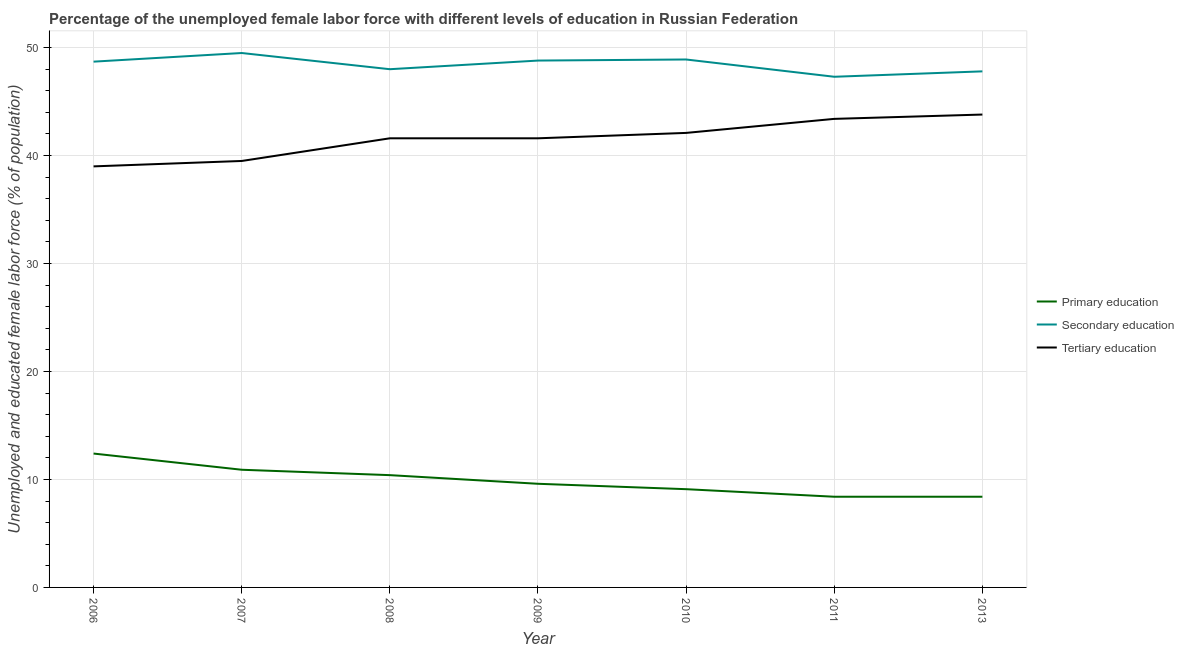Is the number of lines equal to the number of legend labels?
Keep it short and to the point. Yes. What is the percentage of female labor force who received primary education in 2013?
Provide a short and direct response. 8.4. Across all years, what is the maximum percentage of female labor force who received primary education?
Provide a succinct answer. 12.4. Across all years, what is the minimum percentage of female labor force who received secondary education?
Offer a very short reply. 47.3. In which year was the percentage of female labor force who received secondary education maximum?
Keep it short and to the point. 2007. What is the total percentage of female labor force who received tertiary education in the graph?
Your answer should be compact. 291. What is the difference between the percentage of female labor force who received primary education in 2010 and that in 2013?
Make the answer very short. 0.7. What is the difference between the percentage of female labor force who received primary education in 2010 and the percentage of female labor force who received tertiary education in 2006?
Ensure brevity in your answer.  -29.9. What is the average percentage of female labor force who received tertiary education per year?
Make the answer very short. 41.57. In the year 2010, what is the difference between the percentage of female labor force who received secondary education and percentage of female labor force who received primary education?
Keep it short and to the point. 39.8. In how many years, is the percentage of female labor force who received primary education greater than 40 %?
Provide a short and direct response. 0. What is the ratio of the percentage of female labor force who received tertiary education in 2009 to that in 2011?
Offer a terse response. 0.96. What is the difference between the highest and the second highest percentage of female labor force who received tertiary education?
Provide a succinct answer. 0.4. What is the difference between the highest and the lowest percentage of female labor force who received primary education?
Make the answer very short. 4. Is the sum of the percentage of female labor force who received primary education in 2006 and 2008 greater than the maximum percentage of female labor force who received tertiary education across all years?
Provide a short and direct response. No. Is it the case that in every year, the sum of the percentage of female labor force who received primary education and percentage of female labor force who received secondary education is greater than the percentage of female labor force who received tertiary education?
Give a very brief answer. Yes. How many years are there in the graph?
Provide a short and direct response. 7. What is the difference between two consecutive major ticks on the Y-axis?
Provide a short and direct response. 10. Does the graph contain any zero values?
Your response must be concise. No. Does the graph contain grids?
Your response must be concise. Yes. How many legend labels are there?
Provide a succinct answer. 3. What is the title of the graph?
Make the answer very short. Percentage of the unemployed female labor force with different levels of education in Russian Federation. What is the label or title of the Y-axis?
Your answer should be very brief. Unemployed and educated female labor force (% of population). What is the Unemployed and educated female labor force (% of population) in Primary education in 2006?
Your response must be concise. 12.4. What is the Unemployed and educated female labor force (% of population) in Secondary education in 2006?
Offer a terse response. 48.7. What is the Unemployed and educated female labor force (% of population) of Tertiary education in 2006?
Make the answer very short. 39. What is the Unemployed and educated female labor force (% of population) in Primary education in 2007?
Your answer should be compact. 10.9. What is the Unemployed and educated female labor force (% of population) of Secondary education in 2007?
Ensure brevity in your answer.  49.5. What is the Unemployed and educated female labor force (% of population) in Tertiary education in 2007?
Keep it short and to the point. 39.5. What is the Unemployed and educated female labor force (% of population) of Primary education in 2008?
Your answer should be compact. 10.4. What is the Unemployed and educated female labor force (% of population) of Tertiary education in 2008?
Ensure brevity in your answer.  41.6. What is the Unemployed and educated female labor force (% of population) of Primary education in 2009?
Keep it short and to the point. 9.6. What is the Unemployed and educated female labor force (% of population) in Secondary education in 2009?
Your response must be concise. 48.8. What is the Unemployed and educated female labor force (% of population) in Tertiary education in 2009?
Offer a very short reply. 41.6. What is the Unemployed and educated female labor force (% of population) of Primary education in 2010?
Offer a very short reply. 9.1. What is the Unemployed and educated female labor force (% of population) in Secondary education in 2010?
Provide a succinct answer. 48.9. What is the Unemployed and educated female labor force (% of population) in Tertiary education in 2010?
Provide a succinct answer. 42.1. What is the Unemployed and educated female labor force (% of population) of Primary education in 2011?
Give a very brief answer. 8.4. What is the Unemployed and educated female labor force (% of population) of Secondary education in 2011?
Your answer should be compact. 47.3. What is the Unemployed and educated female labor force (% of population) in Tertiary education in 2011?
Offer a terse response. 43.4. What is the Unemployed and educated female labor force (% of population) of Primary education in 2013?
Keep it short and to the point. 8.4. What is the Unemployed and educated female labor force (% of population) of Secondary education in 2013?
Give a very brief answer. 47.8. What is the Unemployed and educated female labor force (% of population) in Tertiary education in 2013?
Offer a very short reply. 43.8. Across all years, what is the maximum Unemployed and educated female labor force (% of population) in Primary education?
Make the answer very short. 12.4. Across all years, what is the maximum Unemployed and educated female labor force (% of population) in Secondary education?
Your answer should be very brief. 49.5. Across all years, what is the maximum Unemployed and educated female labor force (% of population) of Tertiary education?
Provide a short and direct response. 43.8. Across all years, what is the minimum Unemployed and educated female labor force (% of population) of Primary education?
Offer a very short reply. 8.4. Across all years, what is the minimum Unemployed and educated female labor force (% of population) in Secondary education?
Your answer should be very brief. 47.3. What is the total Unemployed and educated female labor force (% of population) in Primary education in the graph?
Your answer should be compact. 69.2. What is the total Unemployed and educated female labor force (% of population) in Secondary education in the graph?
Keep it short and to the point. 339. What is the total Unemployed and educated female labor force (% of population) of Tertiary education in the graph?
Give a very brief answer. 291. What is the difference between the Unemployed and educated female labor force (% of population) of Secondary education in 2006 and that in 2007?
Keep it short and to the point. -0.8. What is the difference between the Unemployed and educated female labor force (% of population) in Primary education in 2006 and that in 2008?
Your response must be concise. 2. What is the difference between the Unemployed and educated female labor force (% of population) of Primary education in 2006 and that in 2009?
Provide a succinct answer. 2.8. What is the difference between the Unemployed and educated female labor force (% of population) in Primary education in 2006 and that in 2010?
Offer a terse response. 3.3. What is the difference between the Unemployed and educated female labor force (% of population) in Secondary education in 2006 and that in 2010?
Your answer should be very brief. -0.2. What is the difference between the Unemployed and educated female labor force (% of population) in Tertiary education in 2006 and that in 2010?
Offer a terse response. -3.1. What is the difference between the Unemployed and educated female labor force (% of population) in Primary education in 2006 and that in 2011?
Make the answer very short. 4. What is the difference between the Unemployed and educated female labor force (% of population) of Secondary education in 2007 and that in 2008?
Keep it short and to the point. 1.5. What is the difference between the Unemployed and educated female labor force (% of population) in Tertiary education in 2007 and that in 2008?
Your answer should be compact. -2.1. What is the difference between the Unemployed and educated female labor force (% of population) of Primary education in 2007 and that in 2009?
Your answer should be compact. 1.3. What is the difference between the Unemployed and educated female labor force (% of population) of Secondary education in 2007 and that in 2009?
Provide a short and direct response. 0.7. What is the difference between the Unemployed and educated female labor force (% of population) in Tertiary education in 2007 and that in 2009?
Offer a very short reply. -2.1. What is the difference between the Unemployed and educated female labor force (% of population) of Primary education in 2007 and that in 2010?
Give a very brief answer. 1.8. What is the difference between the Unemployed and educated female labor force (% of population) of Primary education in 2007 and that in 2011?
Provide a succinct answer. 2.5. What is the difference between the Unemployed and educated female labor force (% of population) in Secondary education in 2007 and that in 2011?
Ensure brevity in your answer.  2.2. What is the difference between the Unemployed and educated female labor force (% of population) of Primary education in 2007 and that in 2013?
Your response must be concise. 2.5. What is the difference between the Unemployed and educated female labor force (% of population) of Tertiary education in 2007 and that in 2013?
Make the answer very short. -4.3. What is the difference between the Unemployed and educated female labor force (% of population) in Tertiary education in 2008 and that in 2009?
Provide a succinct answer. 0. What is the difference between the Unemployed and educated female labor force (% of population) of Primary education in 2008 and that in 2010?
Provide a short and direct response. 1.3. What is the difference between the Unemployed and educated female labor force (% of population) in Secondary education in 2008 and that in 2010?
Ensure brevity in your answer.  -0.9. What is the difference between the Unemployed and educated female labor force (% of population) of Secondary education in 2008 and that in 2011?
Your answer should be very brief. 0.7. What is the difference between the Unemployed and educated female labor force (% of population) of Tertiary education in 2008 and that in 2011?
Keep it short and to the point. -1.8. What is the difference between the Unemployed and educated female labor force (% of population) of Primary education in 2008 and that in 2013?
Ensure brevity in your answer.  2. What is the difference between the Unemployed and educated female labor force (% of population) of Tertiary education in 2008 and that in 2013?
Ensure brevity in your answer.  -2.2. What is the difference between the Unemployed and educated female labor force (% of population) of Secondary education in 2009 and that in 2010?
Provide a succinct answer. -0.1. What is the difference between the Unemployed and educated female labor force (% of population) of Tertiary education in 2009 and that in 2011?
Your response must be concise. -1.8. What is the difference between the Unemployed and educated female labor force (% of population) in Primary education in 2009 and that in 2013?
Keep it short and to the point. 1.2. What is the difference between the Unemployed and educated female labor force (% of population) of Secondary education in 2009 and that in 2013?
Make the answer very short. 1. What is the difference between the Unemployed and educated female labor force (% of population) of Primary education in 2010 and that in 2011?
Provide a short and direct response. 0.7. What is the difference between the Unemployed and educated female labor force (% of population) in Tertiary education in 2010 and that in 2011?
Give a very brief answer. -1.3. What is the difference between the Unemployed and educated female labor force (% of population) in Primary education in 2011 and that in 2013?
Your answer should be compact. 0. What is the difference between the Unemployed and educated female labor force (% of population) in Tertiary education in 2011 and that in 2013?
Your answer should be very brief. -0.4. What is the difference between the Unemployed and educated female labor force (% of population) of Primary education in 2006 and the Unemployed and educated female labor force (% of population) of Secondary education in 2007?
Your response must be concise. -37.1. What is the difference between the Unemployed and educated female labor force (% of population) in Primary education in 2006 and the Unemployed and educated female labor force (% of population) in Tertiary education in 2007?
Your response must be concise. -27.1. What is the difference between the Unemployed and educated female labor force (% of population) of Secondary education in 2006 and the Unemployed and educated female labor force (% of population) of Tertiary education in 2007?
Keep it short and to the point. 9.2. What is the difference between the Unemployed and educated female labor force (% of population) in Primary education in 2006 and the Unemployed and educated female labor force (% of population) in Secondary education in 2008?
Make the answer very short. -35.6. What is the difference between the Unemployed and educated female labor force (% of population) of Primary education in 2006 and the Unemployed and educated female labor force (% of population) of Tertiary education in 2008?
Your response must be concise. -29.2. What is the difference between the Unemployed and educated female labor force (% of population) in Primary education in 2006 and the Unemployed and educated female labor force (% of population) in Secondary education in 2009?
Provide a short and direct response. -36.4. What is the difference between the Unemployed and educated female labor force (% of population) in Primary education in 2006 and the Unemployed and educated female labor force (% of population) in Tertiary education in 2009?
Provide a short and direct response. -29.2. What is the difference between the Unemployed and educated female labor force (% of population) of Secondary education in 2006 and the Unemployed and educated female labor force (% of population) of Tertiary education in 2009?
Keep it short and to the point. 7.1. What is the difference between the Unemployed and educated female labor force (% of population) of Primary education in 2006 and the Unemployed and educated female labor force (% of population) of Secondary education in 2010?
Offer a terse response. -36.5. What is the difference between the Unemployed and educated female labor force (% of population) of Primary education in 2006 and the Unemployed and educated female labor force (% of population) of Tertiary education in 2010?
Make the answer very short. -29.7. What is the difference between the Unemployed and educated female labor force (% of population) in Primary education in 2006 and the Unemployed and educated female labor force (% of population) in Secondary education in 2011?
Make the answer very short. -34.9. What is the difference between the Unemployed and educated female labor force (% of population) in Primary education in 2006 and the Unemployed and educated female labor force (% of population) in Tertiary education in 2011?
Your answer should be very brief. -31. What is the difference between the Unemployed and educated female labor force (% of population) of Primary education in 2006 and the Unemployed and educated female labor force (% of population) of Secondary education in 2013?
Provide a succinct answer. -35.4. What is the difference between the Unemployed and educated female labor force (% of population) in Primary education in 2006 and the Unemployed and educated female labor force (% of population) in Tertiary education in 2013?
Give a very brief answer. -31.4. What is the difference between the Unemployed and educated female labor force (% of population) in Secondary education in 2006 and the Unemployed and educated female labor force (% of population) in Tertiary education in 2013?
Offer a terse response. 4.9. What is the difference between the Unemployed and educated female labor force (% of population) of Primary education in 2007 and the Unemployed and educated female labor force (% of population) of Secondary education in 2008?
Provide a succinct answer. -37.1. What is the difference between the Unemployed and educated female labor force (% of population) of Primary education in 2007 and the Unemployed and educated female labor force (% of population) of Tertiary education in 2008?
Provide a succinct answer. -30.7. What is the difference between the Unemployed and educated female labor force (% of population) in Secondary education in 2007 and the Unemployed and educated female labor force (% of population) in Tertiary education in 2008?
Provide a short and direct response. 7.9. What is the difference between the Unemployed and educated female labor force (% of population) of Primary education in 2007 and the Unemployed and educated female labor force (% of population) of Secondary education in 2009?
Your answer should be very brief. -37.9. What is the difference between the Unemployed and educated female labor force (% of population) in Primary education in 2007 and the Unemployed and educated female labor force (% of population) in Tertiary education in 2009?
Your response must be concise. -30.7. What is the difference between the Unemployed and educated female labor force (% of population) of Secondary education in 2007 and the Unemployed and educated female labor force (% of population) of Tertiary education in 2009?
Ensure brevity in your answer.  7.9. What is the difference between the Unemployed and educated female labor force (% of population) in Primary education in 2007 and the Unemployed and educated female labor force (% of population) in Secondary education in 2010?
Offer a terse response. -38. What is the difference between the Unemployed and educated female labor force (% of population) of Primary education in 2007 and the Unemployed and educated female labor force (% of population) of Tertiary education in 2010?
Ensure brevity in your answer.  -31.2. What is the difference between the Unemployed and educated female labor force (% of population) in Secondary education in 2007 and the Unemployed and educated female labor force (% of population) in Tertiary education in 2010?
Give a very brief answer. 7.4. What is the difference between the Unemployed and educated female labor force (% of population) of Primary education in 2007 and the Unemployed and educated female labor force (% of population) of Secondary education in 2011?
Provide a short and direct response. -36.4. What is the difference between the Unemployed and educated female labor force (% of population) of Primary education in 2007 and the Unemployed and educated female labor force (% of population) of Tertiary education in 2011?
Make the answer very short. -32.5. What is the difference between the Unemployed and educated female labor force (% of population) of Secondary education in 2007 and the Unemployed and educated female labor force (% of population) of Tertiary education in 2011?
Keep it short and to the point. 6.1. What is the difference between the Unemployed and educated female labor force (% of population) of Primary education in 2007 and the Unemployed and educated female labor force (% of population) of Secondary education in 2013?
Keep it short and to the point. -36.9. What is the difference between the Unemployed and educated female labor force (% of population) of Primary education in 2007 and the Unemployed and educated female labor force (% of population) of Tertiary education in 2013?
Ensure brevity in your answer.  -32.9. What is the difference between the Unemployed and educated female labor force (% of population) in Secondary education in 2007 and the Unemployed and educated female labor force (% of population) in Tertiary education in 2013?
Provide a short and direct response. 5.7. What is the difference between the Unemployed and educated female labor force (% of population) of Primary education in 2008 and the Unemployed and educated female labor force (% of population) of Secondary education in 2009?
Keep it short and to the point. -38.4. What is the difference between the Unemployed and educated female labor force (% of population) of Primary education in 2008 and the Unemployed and educated female labor force (% of population) of Tertiary education in 2009?
Keep it short and to the point. -31.2. What is the difference between the Unemployed and educated female labor force (% of population) of Secondary education in 2008 and the Unemployed and educated female labor force (% of population) of Tertiary education in 2009?
Ensure brevity in your answer.  6.4. What is the difference between the Unemployed and educated female labor force (% of population) of Primary education in 2008 and the Unemployed and educated female labor force (% of population) of Secondary education in 2010?
Provide a short and direct response. -38.5. What is the difference between the Unemployed and educated female labor force (% of population) in Primary education in 2008 and the Unemployed and educated female labor force (% of population) in Tertiary education in 2010?
Your response must be concise. -31.7. What is the difference between the Unemployed and educated female labor force (% of population) in Secondary education in 2008 and the Unemployed and educated female labor force (% of population) in Tertiary education in 2010?
Provide a short and direct response. 5.9. What is the difference between the Unemployed and educated female labor force (% of population) in Primary education in 2008 and the Unemployed and educated female labor force (% of population) in Secondary education in 2011?
Keep it short and to the point. -36.9. What is the difference between the Unemployed and educated female labor force (% of population) in Primary education in 2008 and the Unemployed and educated female labor force (% of population) in Tertiary education in 2011?
Provide a short and direct response. -33. What is the difference between the Unemployed and educated female labor force (% of population) in Secondary education in 2008 and the Unemployed and educated female labor force (% of population) in Tertiary education in 2011?
Keep it short and to the point. 4.6. What is the difference between the Unemployed and educated female labor force (% of population) in Primary education in 2008 and the Unemployed and educated female labor force (% of population) in Secondary education in 2013?
Ensure brevity in your answer.  -37.4. What is the difference between the Unemployed and educated female labor force (% of population) of Primary education in 2008 and the Unemployed and educated female labor force (% of population) of Tertiary education in 2013?
Your response must be concise. -33.4. What is the difference between the Unemployed and educated female labor force (% of population) of Primary education in 2009 and the Unemployed and educated female labor force (% of population) of Secondary education in 2010?
Your answer should be compact. -39.3. What is the difference between the Unemployed and educated female labor force (% of population) of Primary education in 2009 and the Unemployed and educated female labor force (% of population) of Tertiary education in 2010?
Provide a short and direct response. -32.5. What is the difference between the Unemployed and educated female labor force (% of population) in Secondary education in 2009 and the Unemployed and educated female labor force (% of population) in Tertiary education in 2010?
Your response must be concise. 6.7. What is the difference between the Unemployed and educated female labor force (% of population) of Primary education in 2009 and the Unemployed and educated female labor force (% of population) of Secondary education in 2011?
Provide a succinct answer. -37.7. What is the difference between the Unemployed and educated female labor force (% of population) in Primary education in 2009 and the Unemployed and educated female labor force (% of population) in Tertiary education in 2011?
Your answer should be very brief. -33.8. What is the difference between the Unemployed and educated female labor force (% of population) in Primary education in 2009 and the Unemployed and educated female labor force (% of population) in Secondary education in 2013?
Provide a short and direct response. -38.2. What is the difference between the Unemployed and educated female labor force (% of population) in Primary education in 2009 and the Unemployed and educated female labor force (% of population) in Tertiary education in 2013?
Make the answer very short. -34.2. What is the difference between the Unemployed and educated female labor force (% of population) of Secondary education in 2009 and the Unemployed and educated female labor force (% of population) of Tertiary education in 2013?
Provide a succinct answer. 5. What is the difference between the Unemployed and educated female labor force (% of population) of Primary education in 2010 and the Unemployed and educated female labor force (% of population) of Secondary education in 2011?
Provide a succinct answer. -38.2. What is the difference between the Unemployed and educated female labor force (% of population) in Primary education in 2010 and the Unemployed and educated female labor force (% of population) in Tertiary education in 2011?
Make the answer very short. -34.3. What is the difference between the Unemployed and educated female labor force (% of population) of Primary education in 2010 and the Unemployed and educated female labor force (% of population) of Secondary education in 2013?
Your answer should be compact. -38.7. What is the difference between the Unemployed and educated female labor force (% of population) of Primary education in 2010 and the Unemployed and educated female labor force (% of population) of Tertiary education in 2013?
Your answer should be very brief. -34.7. What is the difference between the Unemployed and educated female labor force (% of population) of Secondary education in 2010 and the Unemployed and educated female labor force (% of population) of Tertiary education in 2013?
Provide a short and direct response. 5.1. What is the difference between the Unemployed and educated female labor force (% of population) in Primary education in 2011 and the Unemployed and educated female labor force (% of population) in Secondary education in 2013?
Ensure brevity in your answer.  -39.4. What is the difference between the Unemployed and educated female labor force (% of population) of Primary education in 2011 and the Unemployed and educated female labor force (% of population) of Tertiary education in 2013?
Offer a terse response. -35.4. What is the average Unemployed and educated female labor force (% of population) in Primary education per year?
Provide a short and direct response. 9.89. What is the average Unemployed and educated female labor force (% of population) of Secondary education per year?
Provide a succinct answer. 48.43. What is the average Unemployed and educated female labor force (% of population) of Tertiary education per year?
Provide a succinct answer. 41.57. In the year 2006, what is the difference between the Unemployed and educated female labor force (% of population) in Primary education and Unemployed and educated female labor force (% of population) in Secondary education?
Give a very brief answer. -36.3. In the year 2006, what is the difference between the Unemployed and educated female labor force (% of population) of Primary education and Unemployed and educated female labor force (% of population) of Tertiary education?
Give a very brief answer. -26.6. In the year 2007, what is the difference between the Unemployed and educated female labor force (% of population) in Primary education and Unemployed and educated female labor force (% of population) in Secondary education?
Offer a very short reply. -38.6. In the year 2007, what is the difference between the Unemployed and educated female labor force (% of population) in Primary education and Unemployed and educated female labor force (% of population) in Tertiary education?
Provide a short and direct response. -28.6. In the year 2008, what is the difference between the Unemployed and educated female labor force (% of population) in Primary education and Unemployed and educated female labor force (% of population) in Secondary education?
Your answer should be compact. -37.6. In the year 2008, what is the difference between the Unemployed and educated female labor force (% of population) of Primary education and Unemployed and educated female labor force (% of population) of Tertiary education?
Your response must be concise. -31.2. In the year 2009, what is the difference between the Unemployed and educated female labor force (% of population) of Primary education and Unemployed and educated female labor force (% of population) of Secondary education?
Provide a short and direct response. -39.2. In the year 2009, what is the difference between the Unemployed and educated female labor force (% of population) in Primary education and Unemployed and educated female labor force (% of population) in Tertiary education?
Make the answer very short. -32. In the year 2009, what is the difference between the Unemployed and educated female labor force (% of population) in Secondary education and Unemployed and educated female labor force (% of population) in Tertiary education?
Offer a terse response. 7.2. In the year 2010, what is the difference between the Unemployed and educated female labor force (% of population) of Primary education and Unemployed and educated female labor force (% of population) of Secondary education?
Give a very brief answer. -39.8. In the year 2010, what is the difference between the Unemployed and educated female labor force (% of population) of Primary education and Unemployed and educated female labor force (% of population) of Tertiary education?
Make the answer very short. -33. In the year 2010, what is the difference between the Unemployed and educated female labor force (% of population) of Secondary education and Unemployed and educated female labor force (% of population) of Tertiary education?
Offer a terse response. 6.8. In the year 2011, what is the difference between the Unemployed and educated female labor force (% of population) of Primary education and Unemployed and educated female labor force (% of population) of Secondary education?
Make the answer very short. -38.9. In the year 2011, what is the difference between the Unemployed and educated female labor force (% of population) in Primary education and Unemployed and educated female labor force (% of population) in Tertiary education?
Provide a succinct answer. -35. In the year 2011, what is the difference between the Unemployed and educated female labor force (% of population) in Secondary education and Unemployed and educated female labor force (% of population) in Tertiary education?
Your answer should be very brief. 3.9. In the year 2013, what is the difference between the Unemployed and educated female labor force (% of population) of Primary education and Unemployed and educated female labor force (% of population) of Secondary education?
Give a very brief answer. -39.4. In the year 2013, what is the difference between the Unemployed and educated female labor force (% of population) in Primary education and Unemployed and educated female labor force (% of population) in Tertiary education?
Your response must be concise. -35.4. What is the ratio of the Unemployed and educated female labor force (% of population) in Primary education in 2006 to that in 2007?
Offer a terse response. 1.14. What is the ratio of the Unemployed and educated female labor force (% of population) in Secondary education in 2006 to that in 2007?
Ensure brevity in your answer.  0.98. What is the ratio of the Unemployed and educated female labor force (% of population) of Tertiary education in 2006 to that in 2007?
Keep it short and to the point. 0.99. What is the ratio of the Unemployed and educated female labor force (% of population) of Primary education in 2006 to that in 2008?
Offer a terse response. 1.19. What is the ratio of the Unemployed and educated female labor force (% of population) of Secondary education in 2006 to that in 2008?
Ensure brevity in your answer.  1.01. What is the ratio of the Unemployed and educated female labor force (% of population) in Primary education in 2006 to that in 2009?
Provide a short and direct response. 1.29. What is the ratio of the Unemployed and educated female labor force (% of population) in Primary education in 2006 to that in 2010?
Your response must be concise. 1.36. What is the ratio of the Unemployed and educated female labor force (% of population) in Tertiary education in 2006 to that in 2010?
Give a very brief answer. 0.93. What is the ratio of the Unemployed and educated female labor force (% of population) in Primary education in 2006 to that in 2011?
Your response must be concise. 1.48. What is the ratio of the Unemployed and educated female labor force (% of population) in Secondary education in 2006 to that in 2011?
Make the answer very short. 1.03. What is the ratio of the Unemployed and educated female labor force (% of population) of Tertiary education in 2006 to that in 2011?
Ensure brevity in your answer.  0.9. What is the ratio of the Unemployed and educated female labor force (% of population) in Primary education in 2006 to that in 2013?
Provide a short and direct response. 1.48. What is the ratio of the Unemployed and educated female labor force (% of population) of Secondary education in 2006 to that in 2013?
Offer a terse response. 1.02. What is the ratio of the Unemployed and educated female labor force (% of population) in Tertiary education in 2006 to that in 2013?
Provide a short and direct response. 0.89. What is the ratio of the Unemployed and educated female labor force (% of population) of Primary education in 2007 to that in 2008?
Give a very brief answer. 1.05. What is the ratio of the Unemployed and educated female labor force (% of population) in Secondary education in 2007 to that in 2008?
Provide a short and direct response. 1.03. What is the ratio of the Unemployed and educated female labor force (% of population) in Tertiary education in 2007 to that in 2008?
Your answer should be compact. 0.95. What is the ratio of the Unemployed and educated female labor force (% of population) of Primary education in 2007 to that in 2009?
Ensure brevity in your answer.  1.14. What is the ratio of the Unemployed and educated female labor force (% of population) of Secondary education in 2007 to that in 2009?
Ensure brevity in your answer.  1.01. What is the ratio of the Unemployed and educated female labor force (% of population) of Tertiary education in 2007 to that in 2009?
Your answer should be very brief. 0.95. What is the ratio of the Unemployed and educated female labor force (% of population) of Primary education in 2007 to that in 2010?
Your answer should be very brief. 1.2. What is the ratio of the Unemployed and educated female labor force (% of population) of Secondary education in 2007 to that in 2010?
Give a very brief answer. 1.01. What is the ratio of the Unemployed and educated female labor force (% of population) in Tertiary education in 2007 to that in 2010?
Your response must be concise. 0.94. What is the ratio of the Unemployed and educated female labor force (% of population) in Primary education in 2007 to that in 2011?
Provide a succinct answer. 1.3. What is the ratio of the Unemployed and educated female labor force (% of population) of Secondary education in 2007 to that in 2011?
Give a very brief answer. 1.05. What is the ratio of the Unemployed and educated female labor force (% of population) of Tertiary education in 2007 to that in 2011?
Ensure brevity in your answer.  0.91. What is the ratio of the Unemployed and educated female labor force (% of population) in Primary education in 2007 to that in 2013?
Ensure brevity in your answer.  1.3. What is the ratio of the Unemployed and educated female labor force (% of population) in Secondary education in 2007 to that in 2013?
Offer a very short reply. 1.04. What is the ratio of the Unemployed and educated female labor force (% of population) of Tertiary education in 2007 to that in 2013?
Ensure brevity in your answer.  0.9. What is the ratio of the Unemployed and educated female labor force (% of population) of Secondary education in 2008 to that in 2009?
Give a very brief answer. 0.98. What is the ratio of the Unemployed and educated female labor force (% of population) of Tertiary education in 2008 to that in 2009?
Your answer should be compact. 1. What is the ratio of the Unemployed and educated female labor force (% of population) of Secondary education in 2008 to that in 2010?
Ensure brevity in your answer.  0.98. What is the ratio of the Unemployed and educated female labor force (% of population) in Primary education in 2008 to that in 2011?
Keep it short and to the point. 1.24. What is the ratio of the Unemployed and educated female labor force (% of population) in Secondary education in 2008 to that in 2011?
Your answer should be compact. 1.01. What is the ratio of the Unemployed and educated female labor force (% of population) of Tertiary education in 2008 to that in 2011?
Your answer should be very brief. 0.96. What is the ratio of the Unemployed and educated female labor force (% of population) in Primary education in 2008 to that in 2013?
Offer a very short reply. 1.24. What is the ratio of the Unemployed and educated female labor force (% of population) of Tertiary education in 2008 to that in 2013?
Your answer should be very brief. 0.95. What is the ratio of the Unemployed and educated female labor force (% of population) in Primary education in 2009 to that in 2010?
Keep it short and to the point. 1.05. What is the ratio of the Unemployed and educated female labor force (% of population) of Secondary education in 2009 to that in 2010?
Ensure brevity in your answer.  1. What is the ratio of the Unemployed and educated female labor force (% of population) of Primary education in 2009 to that in 2011?
Provide a short and direct response. 1.14. What is the ratio of the Unemployed and educated female labor force (% of population) in Secondary education in 2009 to that in 2011?
Give a very brief answer. 1.03. What is the ratio of the Unemployed and educated female labor force (% of population) of Tertiary education in 2009 to that in 2011?
Provide a short and direct response. 0.96. What is the ratio of the Unemployed and educated female labor force (% of population) of Secondary education in 2009 to that in 2013?
Keep it short and to the point. 1.02. What is the ratio of the Unemployed and educated female labor force (% of population) in Tertiary education in 2009 to that in 2013?
Your answer should be compact. 0.95. What is the ratio of the Unemployed and educated female labor force (% of population) in Secondary education in 2010 to that in 2011?
Your answer should be very brief. 1.03. What is the ratio of the Unemployed and educated female labor force (% of population) of Tertiary education in 2010 to that in 2011?
Provide a succinct answer. 0.97. What is the ratio of the Unemployed and educated female labor force (% of population) of Primary education in 2010 to that in 2013?
Provide a short and direct response. 1.08. What is the ratio of the Unemployed and educated female labor force (% of population) in Tertiary education in 2010 to that in 2013?
Your answer should be very brief. 0.96. What is the ratio of the Unemployed and educated female labor force (% of population) of Primary education in 2011 to that in 2013?
Offer a terse response. 1. What is the ratio of the Unemployed and educated female labor force (% of population) of Secondary education in 2011 to that in 2013?
Make the answer very short. 0.99. What is the ratio of the Unemployed and educated female labor force (% of population) of Tertiary education in 2011 to that in 2013?
Your answer should be compact. 0.99. What is the difference between the highest and the second highest Unemployed and educated female labor force (% of population) in Secondary education?
Your answer should be compact. 0.6. What is the difference between the highest and the lowest Unemployed and educated female labor force (% of population) in Primary education?
Provide a short and direct response. 4. What is the difference between the highest and the lowest Unemployed and educated female labor force (% of population) of Secondary education?
Keep it short and to the point. 2.2. 